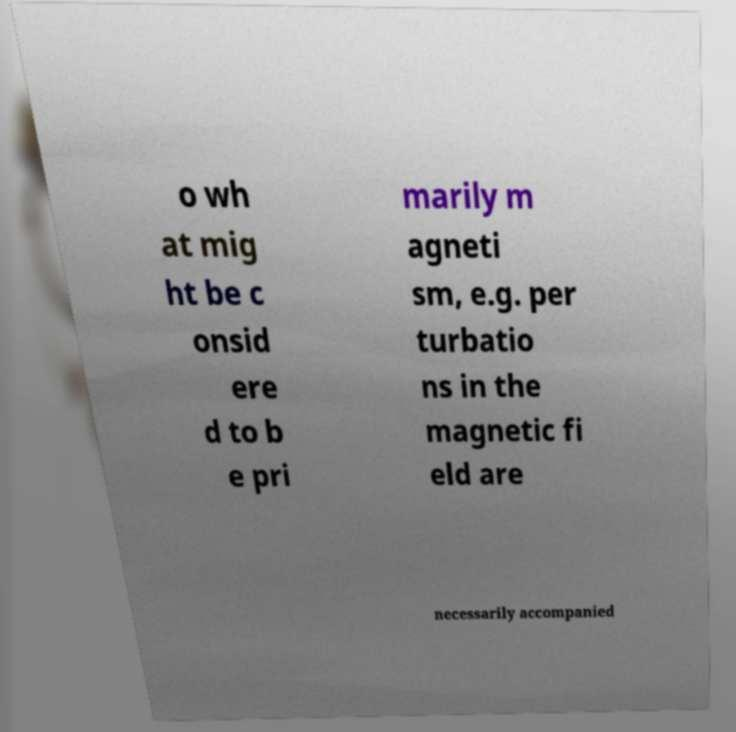For documentation purposes, I need the text within this image transcribed. Could you provide that? o wh at mig ht be c onsid ere d to b e pri marily m agneti sm, e.g. per turbatio ns in the magnetic fi eld are necessarily accompanied 